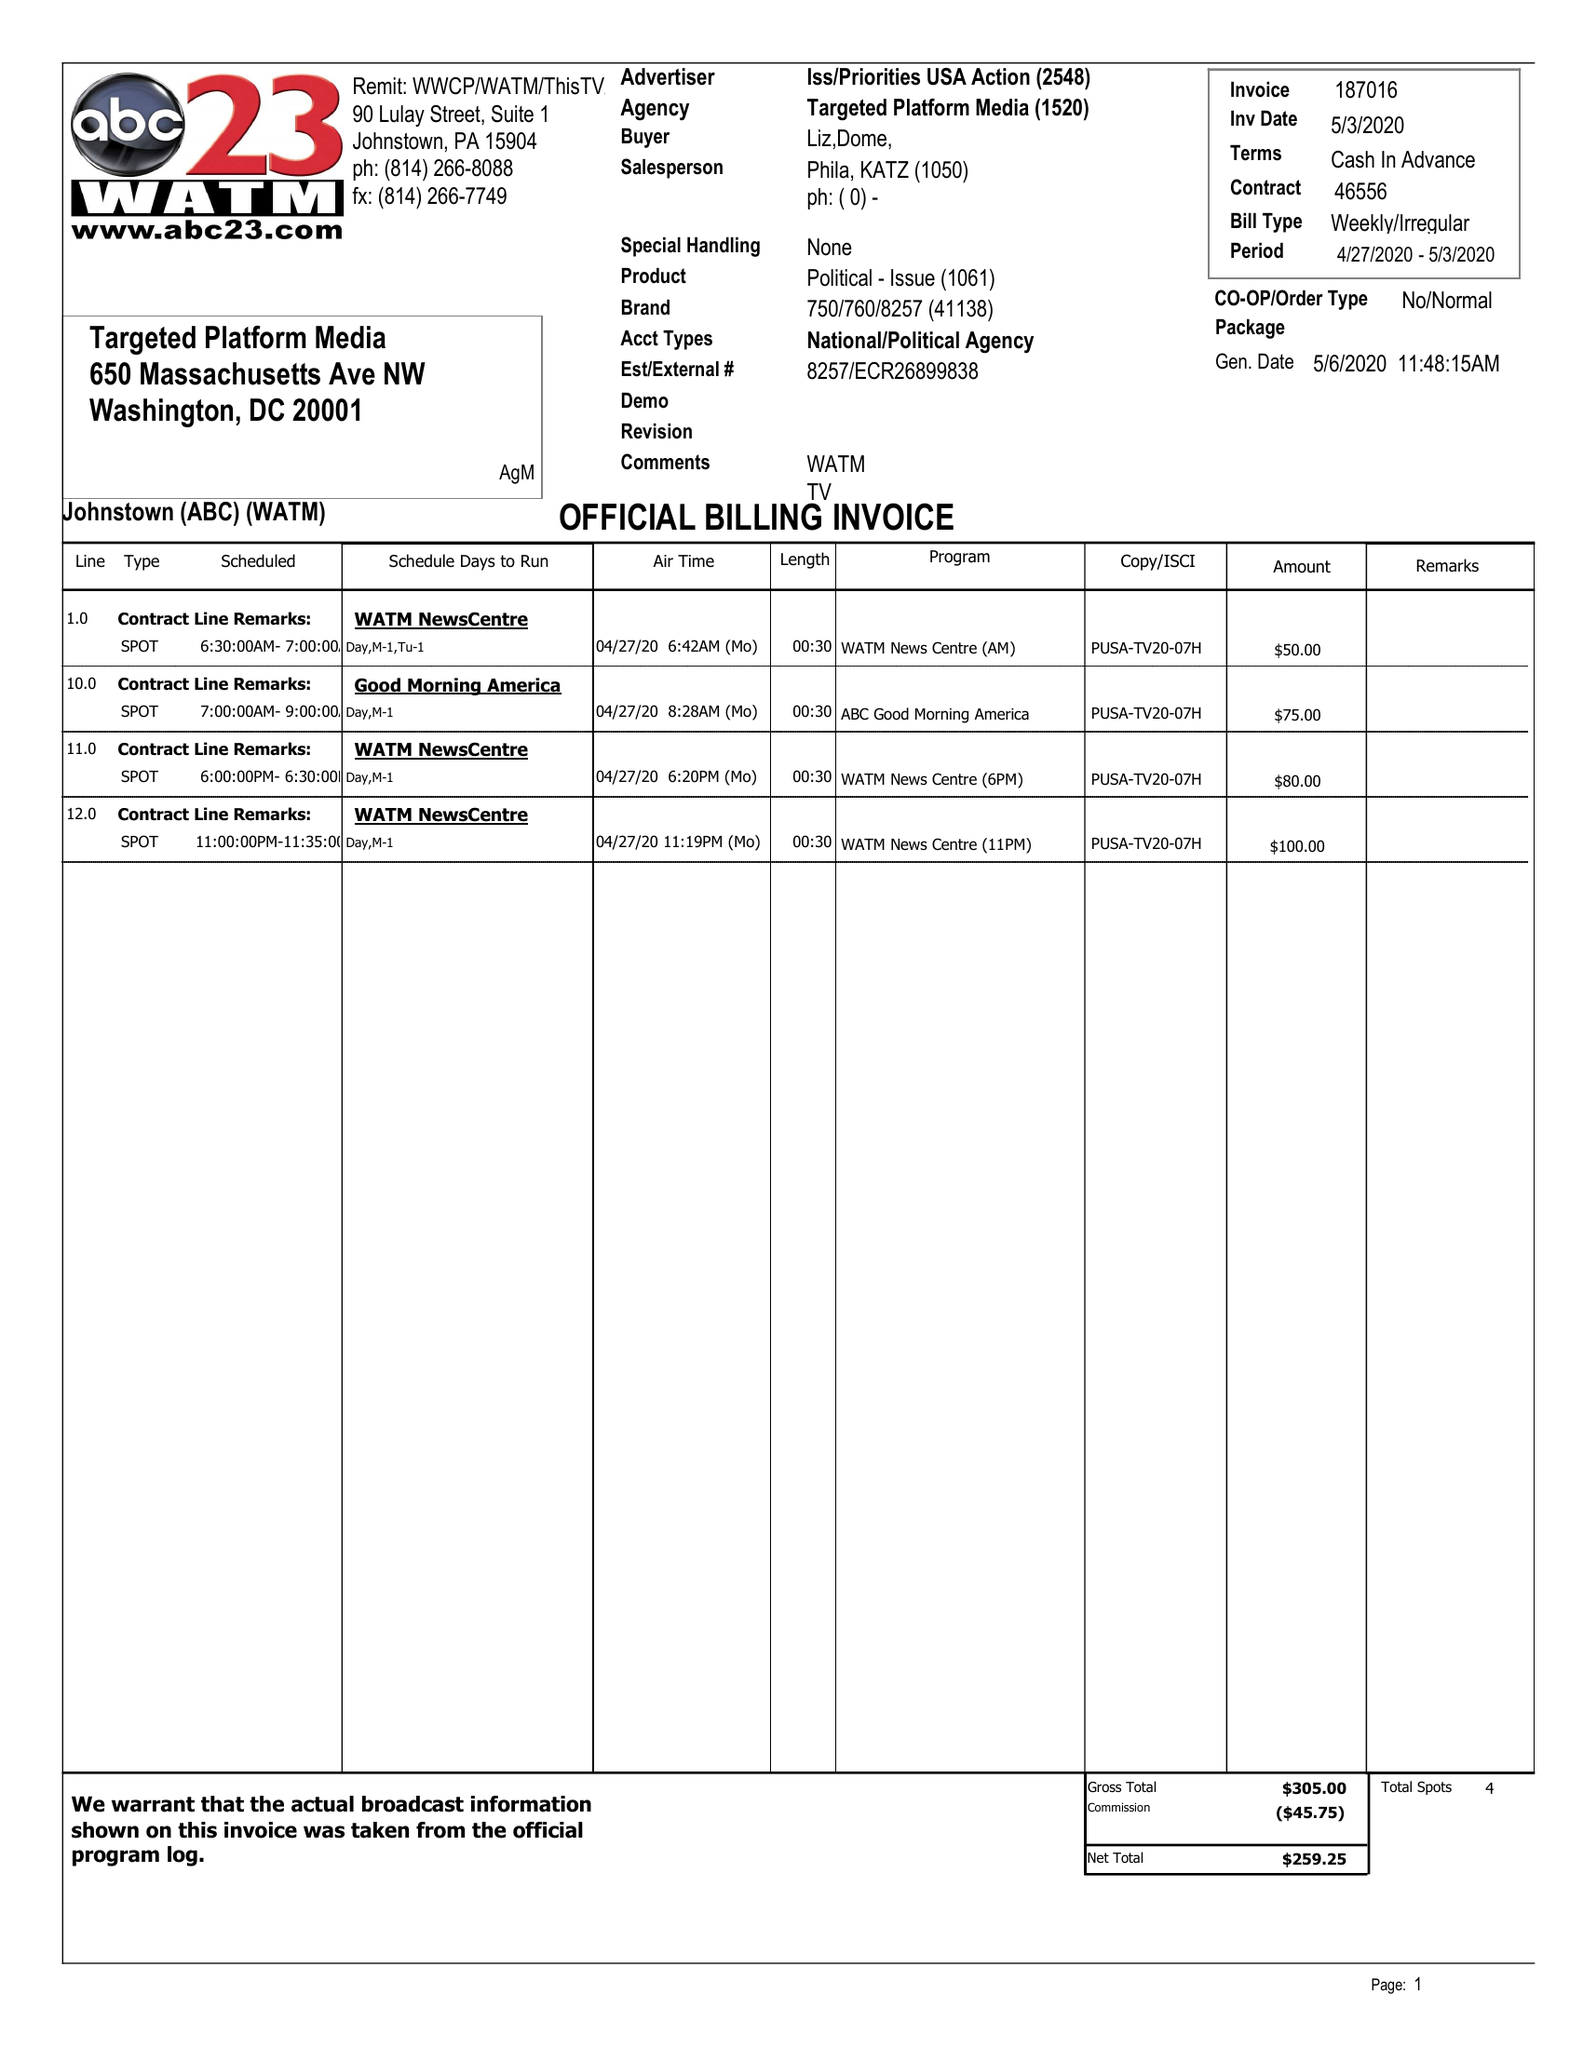What is the value for the contract_num?
Answer the question using a single word or phrase. 46556 